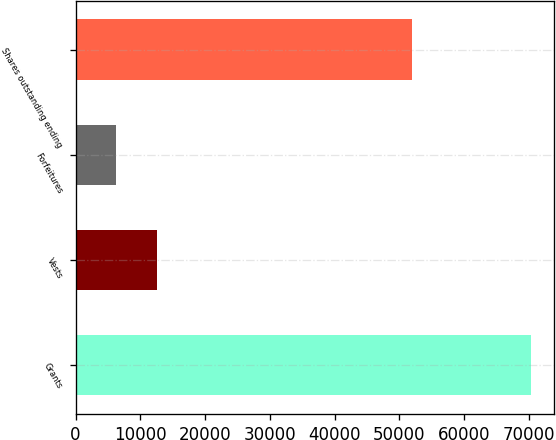Convert chart. <chart><loc_0><loc_0><loc_500><loc_500><bar_chart><fcel>Grants<fcel>Vests<fcel>Forfeitures<fcel>Shares outstanding ending<nl><fcel>70341<fcel>12588.9<fcel>6172<fcel>51996<nl></chart> 